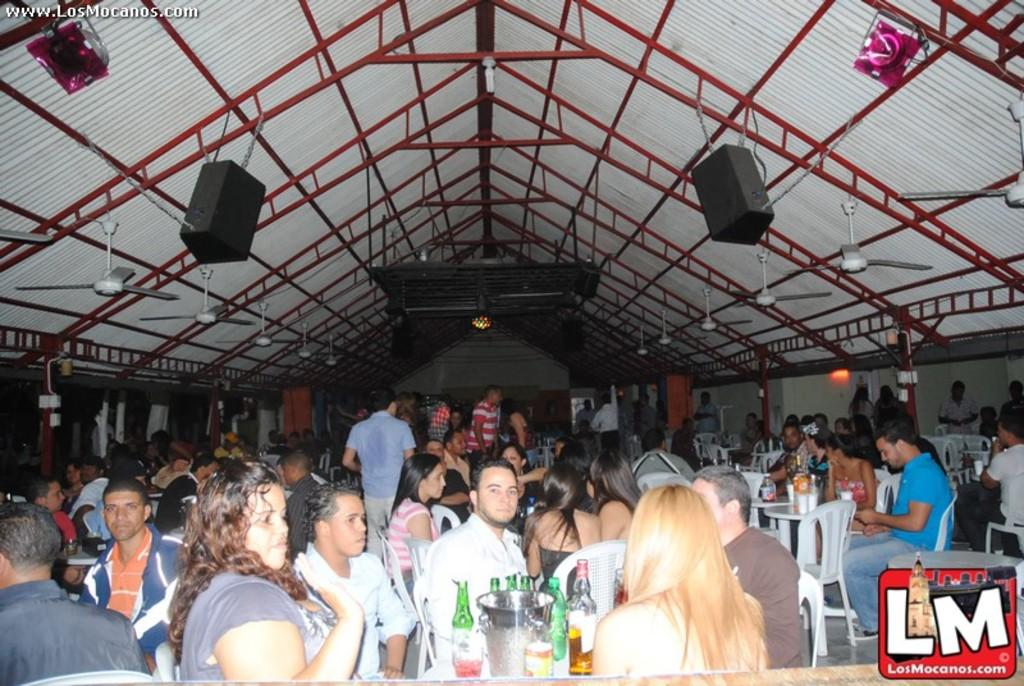What are the people in the image doing? There is a group of people sitting on chairs in the image. What can be seen on the tables in the image? There are objects on the tables in the image. What type of beverages are visible in the image? There are wine bottles visible in the image. What devices are present in the image for cooling or entertainment? There are fans and speakers in the image. What type of structure is present in the background of the image? There is a shed in the image. What type of jeans are being worn by the seashore in the image? There is no seashore or jeans present in the image. What scientific theory is being discussed by the people in the image? There is no indication in the image of a scientific theory being discussed. 